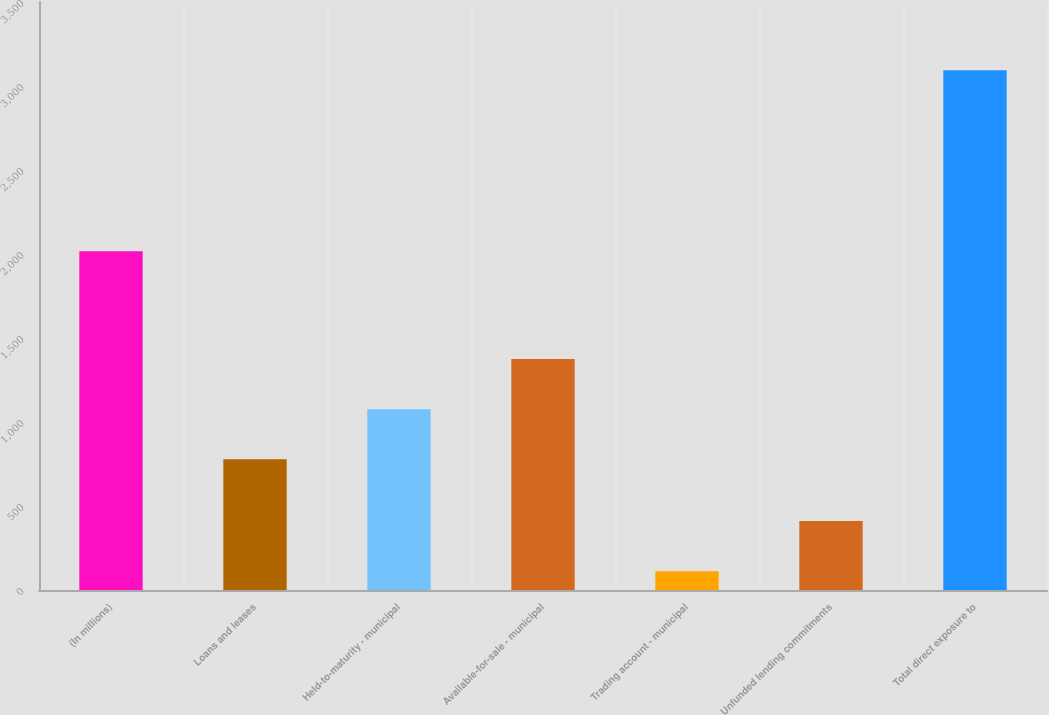Convert chart. <chart><loc_0><loc_0><loc_500><loc_500><bar_chart><fcel>(In millions)<fcel>Loans and leases<fcel>Held-to-maturity - municipal<fcel>Available-for-sale - municipal<fcel>Trading account - municipal<fcel>Unfunded lending commitments<fcel>Total direct exposure to<nl><fcel>2016<fcel>778<fcel>1076.2<fcel>1374.4<fcel>112<fcel>410.2<fcel>3094<nl></chart> 